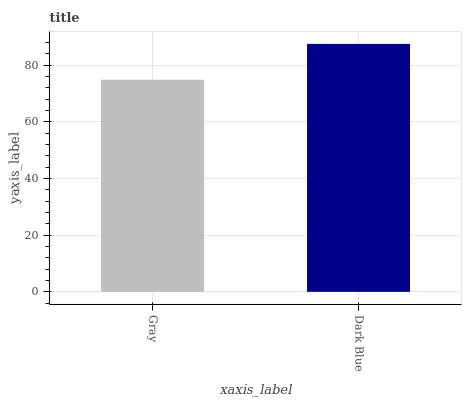Is Gray the minimum?
Answer yes or no. Yes. Is Dark Blue the maximum?
Answer yes or no. Yes. Is Dark Blue the minimum?
Answer yes or no. No. Is Dark Blue greater than Gray?
Answer yes or no. Yes. Is Gray less than Dark Blue?
Answer yes or no. Yes. Is Gray greater than Dark Blue?
Answer yes or no. No. Is Dark Blue less than Gray?
Answer yes or no. No. Is Dark Blue the high median?
Answer yes or no. Yes. Is Gray the low median?
Answer yes or no. Yes. Is Gray the high median?
Answer yes or no. No. Is Dark Blue the low median?
Answer yes or no. No. 